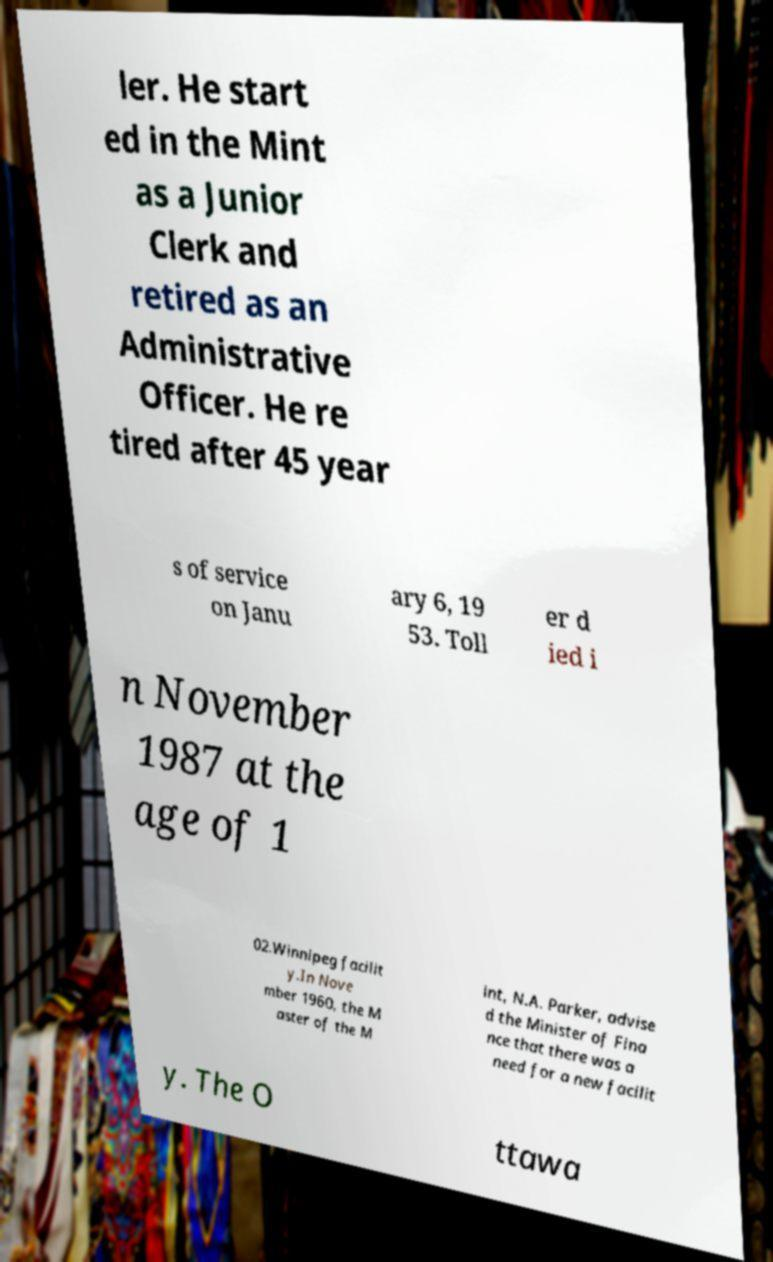Could you extract and type out the text from this image? ler. He start ed in the Mint as a Junior Clerk and retired as an Administrative Officer. He re tired after 45 year s of service on Janu ary 6, 19 53. Toll er d ied i n November 1987 at the age of 1 02.Winnipeg facilit y.In Nove mber 1960, the M aster of the M int, N.A. Parker, advise d the Minister of Fina nce that there was a need for a new facilit y. The O ttawa 